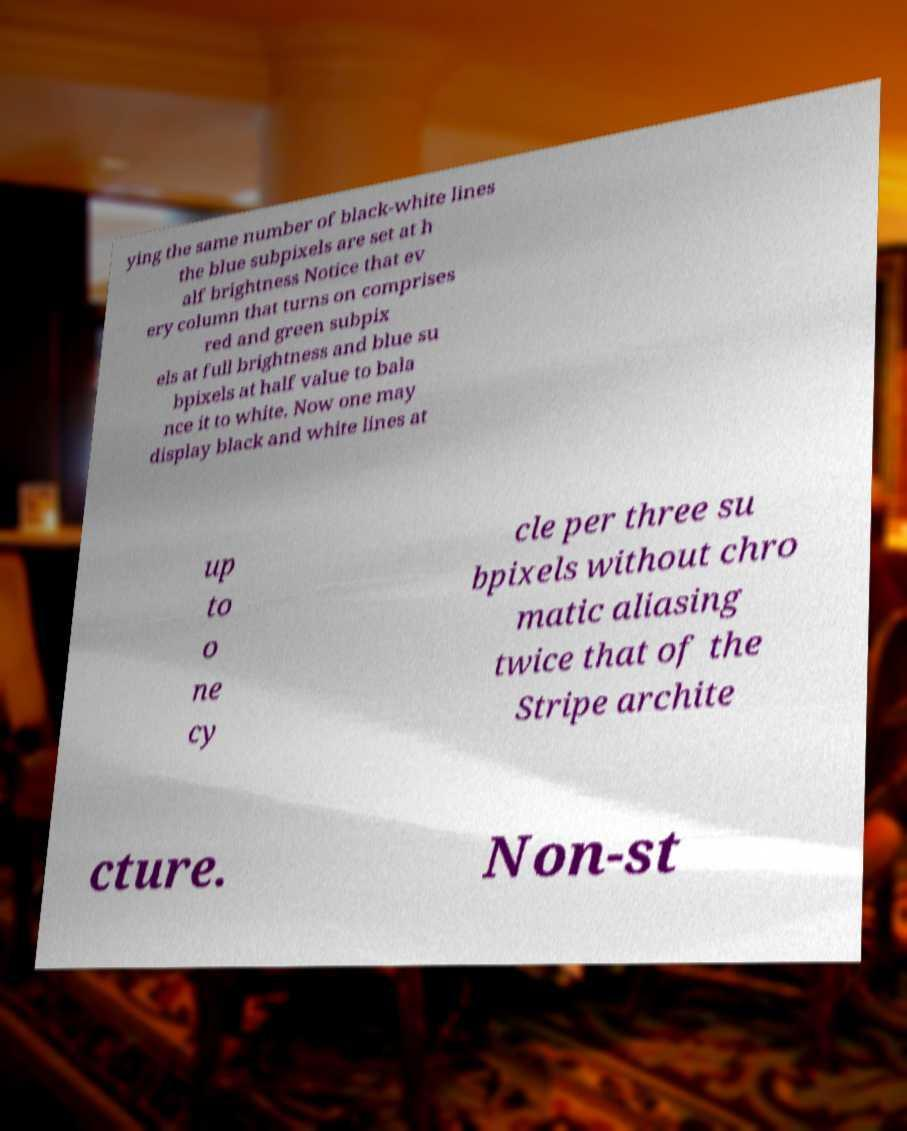What messages or text are displayed in this image? I need them in a readable, typed format. ying the same number of black-white lines the blue subpixels are set at h alf brightness Notice that ev ery column that turns on comprises red and green subpix els at full brightness and blue su bpixels at half value to bala nce it to white. Now one may display black and white lines at up to o ne cy cle per three su bpixels without chro matic aliasing twice that of the Stripe archite cture. Non-st 